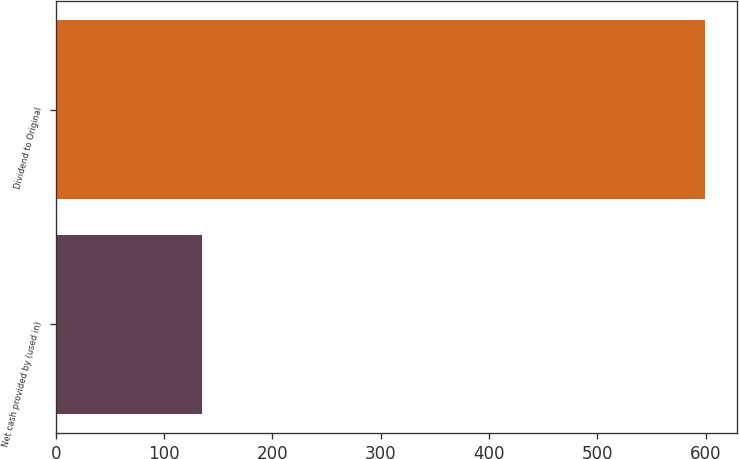Convert chart. <chart><loc_0><loc_0><loc_500><loc_500><bar_chart><fcel>Net cash provided by (used in)<fcel>Dividend to Original<nl><fcel>135<fcel>599<nl></chart> 